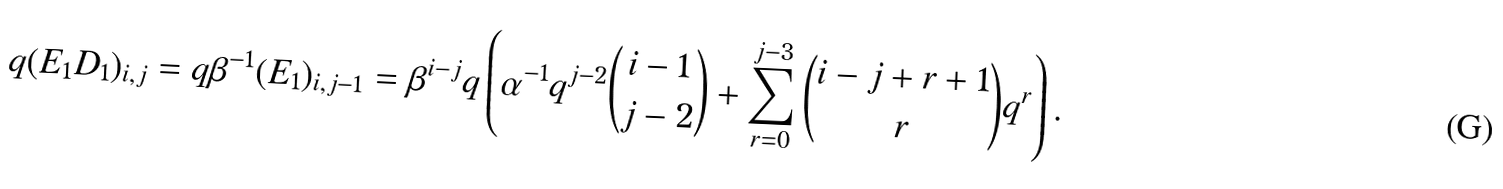Convert formula to latex. <formula><loc_0><loc_0><loc_500><loc_500>q ( E _ { 1 } D _ { 1 } ) _ { i , j } = q \beta ^ { - 1 } ( E _ { 1 } ) _ { i , j - 1 } = \beta ^ { i - j } q \left ( \alpha ^ { - 1 } q ^ { j - 2 } { i - 1 \choose j - 2 } + \sum _ { r = 0 } ^ { j - 3 } { i - j + r + 1 \choose r } q ^ { r } \right ) .</formula> 